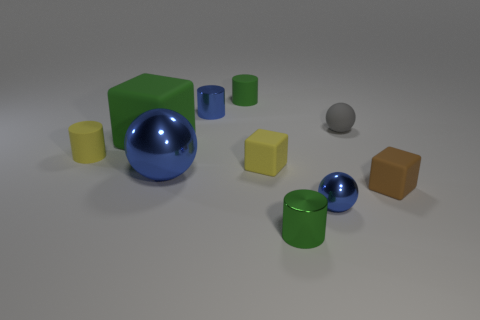There is a small metal cylinder that is to the left of the green cylinder that is to the right of the tiny green matte thing; how many small green cylinders are behind it?
Give a very brief answer. 1. How many metal things are small yellow objects or small blue things?
Your response must be concise. 2. There is a ball that is in front of the cube that is on the right side of the small gray ball; how big is it?
Make the answer very short. Small. There is a block behind the small yellow cylinder; is it the same color as the tiny thing to the right of the small gray rubber object?
Your response must be concise. No. The ball that is behind the brown thing and right of the tiny blue cylinder is what color?
Make the answer very short. Gray. Are the small blue cylinder and the small yellow cylinder made of the same material?
Your answer should be very brief. No. How many big objects are blue metal cylinders or cyan balls?
Keep it short and to the point. 0. Is there anything else that is the same shape as the big metal object?
Make the answer very short. Yes. Are there any other things that have the same size as the brown cube?
Ensure brevity in your answer.  Yes. The other small cylinder that is made of the same material as the small blue cylinder is what color?
Your response must be concise. Green. 